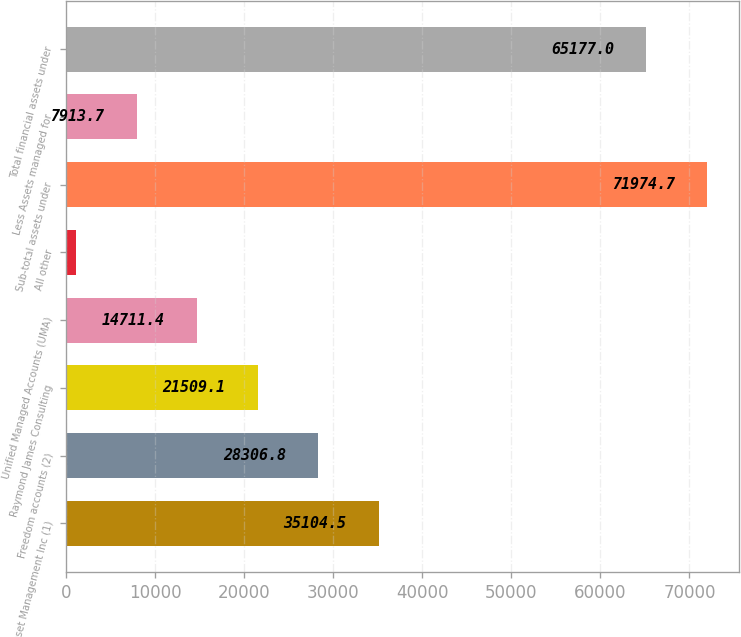Convert chart to OTSL. <chart><loc_0><loc_0><loc_500><loc_500><bar_chart><fcel>Eagle Asset Management Inc (1)<fcel>Freedom accounts (2)<fcel>Raymond James Consulting<fcel>Unified Managed Accounts (UMA)<fcel>All other<fcel>Sub-total assets under<fcel>Less Assets managed for<fcel>Total financial assets under<nl><fcel>35104.5<fcel>28306.8<fcel>21509.1<fcel>14711.4<fcel>1116<fcel>71974.7<fcel>7913.7<fcel>65177<nl></chart> 